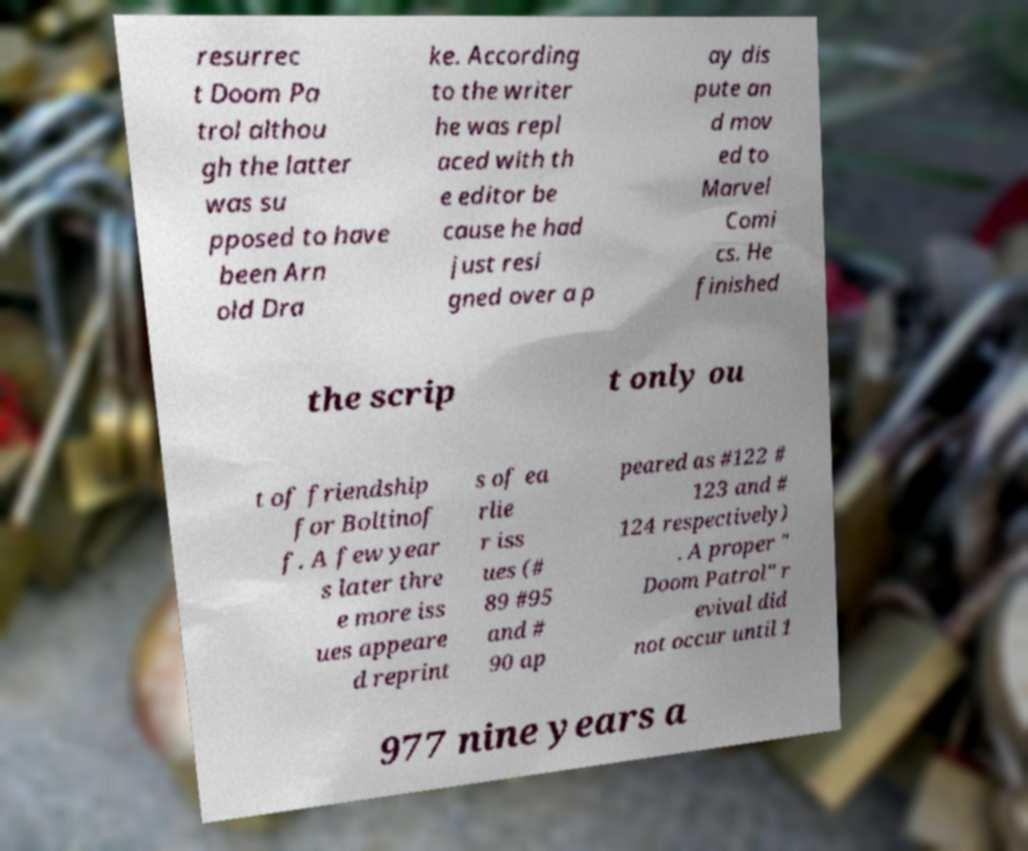Please identify and transcribe the text found in this image. resurrec t Doom Pa trol althou gh the latter was su pposed to have been Arn old Dra ke. According to the writer he was repl aced with th e editor be cause he had just resi gned over a p ay dis pute an d mov ed to Marvel Comi cs. He finished the scrip t only ou t of friendship for Boltinof f. A few year s later thre e more iss ues appeare d reprint s of ea rlie r iss ues (# 89 #95 and # 90 ap peared as #122 # 123 and # 124 respectively) . A proper " Doom Patrol" r evival did not occur until 1 977 nine years a 